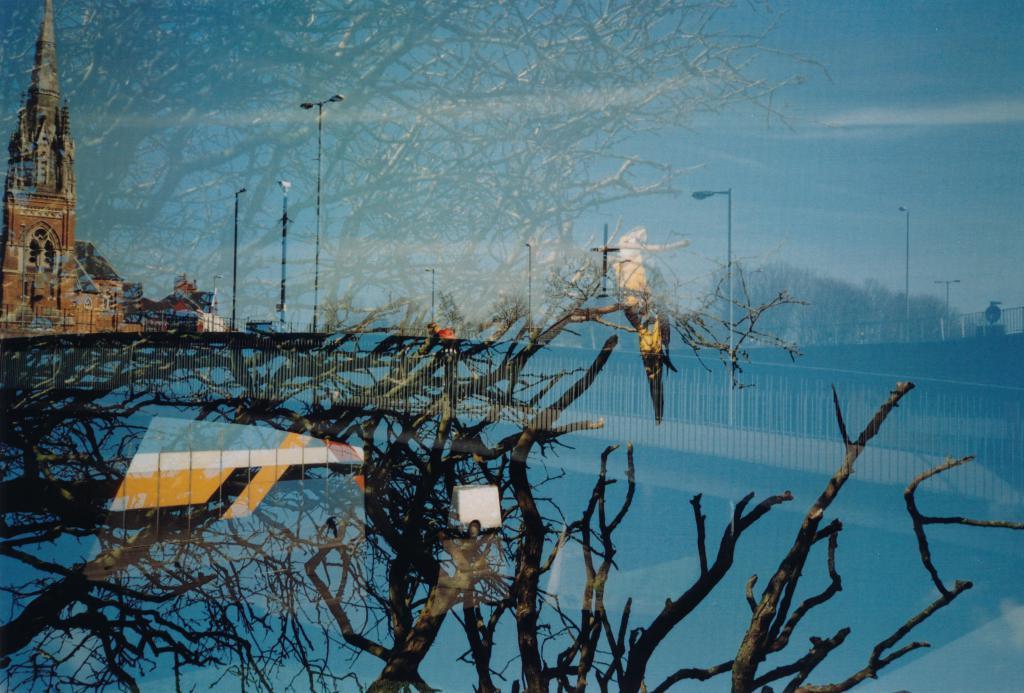Can you describe this image briefly? In the picture it looks like a reflection there is a tree, a bird, a fence, street lights, church and few other things can be seen on a surface. 